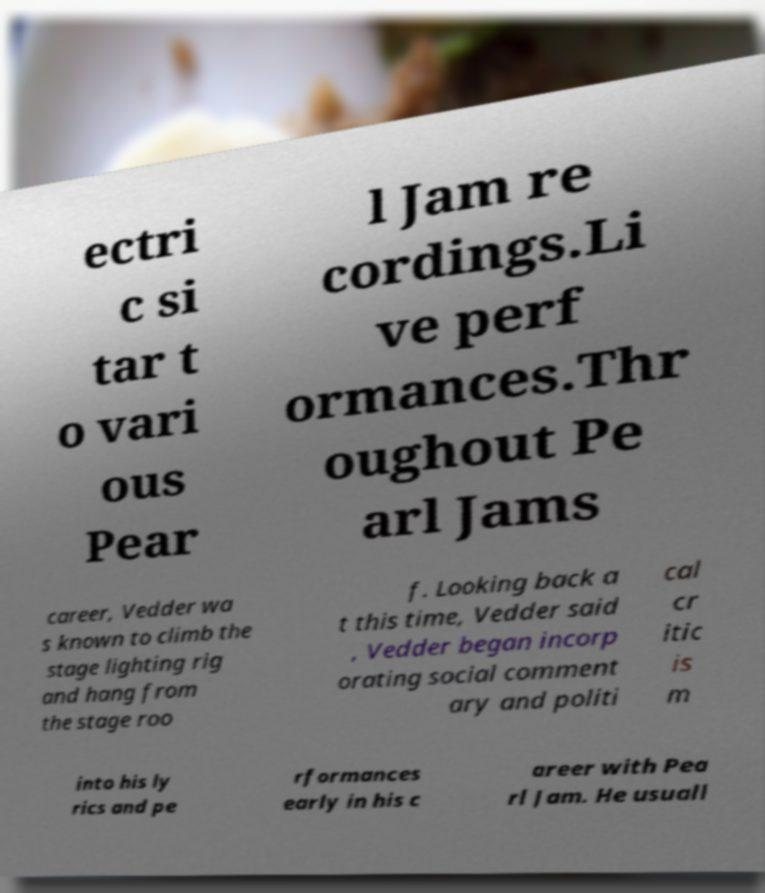There's text embedded in this image that I need extracted. Can you transcribe it verbatim? ectri c si tar t o vari ous Pear l Jam re cordings.Li ve perf ormances.Thr oughout Pe arl Jams career, Vedder wa s known to climb the stage lighting rig and hang from the stage roo f. Looking back a t this time, Vedder said , Vedder began incorp orating social comment ary and politi cal cr itic is m into his ly rics and pe rformances early in his c areer with Pea rl Jam. He usuall 